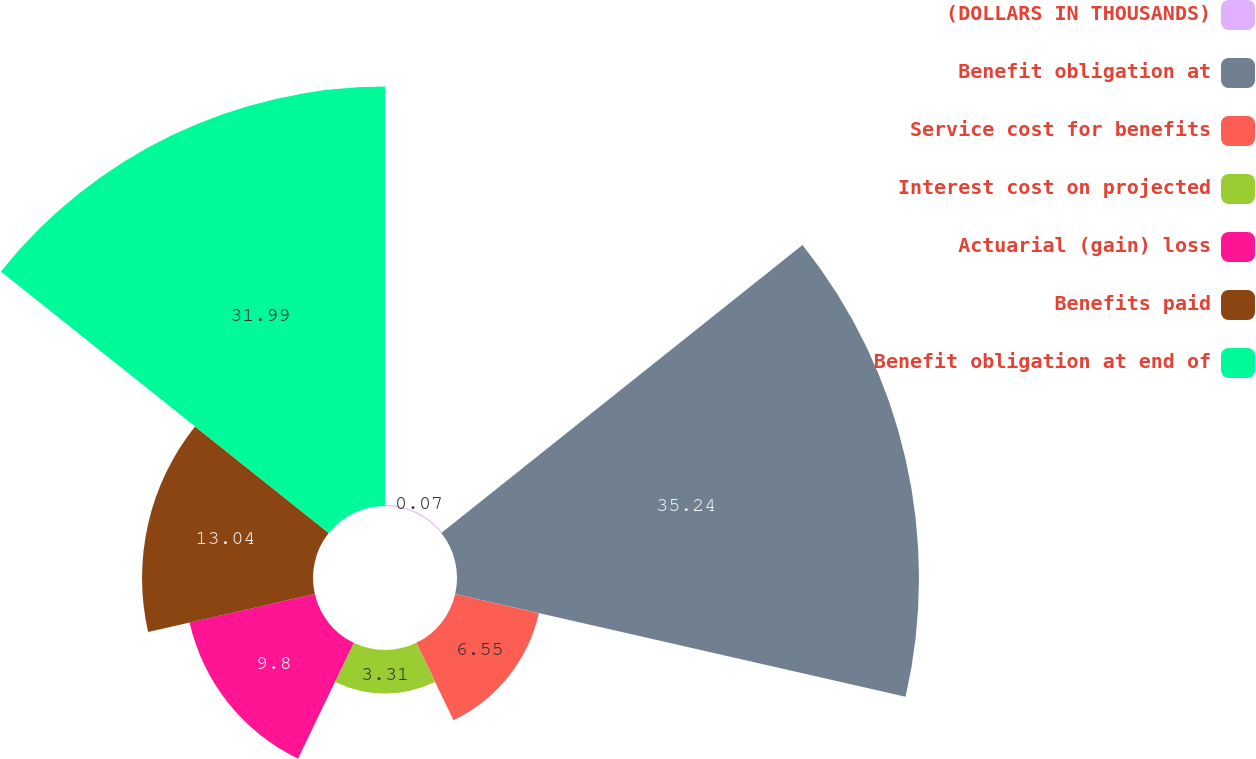Convert chart. <chart><loc_0><loc_0><loc_500><loc_500><pie_chart><fcel>(DOLLARS IN THOUSANDS)<fcel>Benefit obligation at<fcel>Service cost for benefits<fcel>Interest cost on projected<fcel>Actuarial (gain) loss<fcel>Benefits paid<fcel>Benefit obligation at end of<nl><fcel>0.07%<fcel>35.24%<fcel>6.55%<fcel>3.31%<fcel>9.8%<fcel>13.04%<fcel>31.99%<nl></chart> 